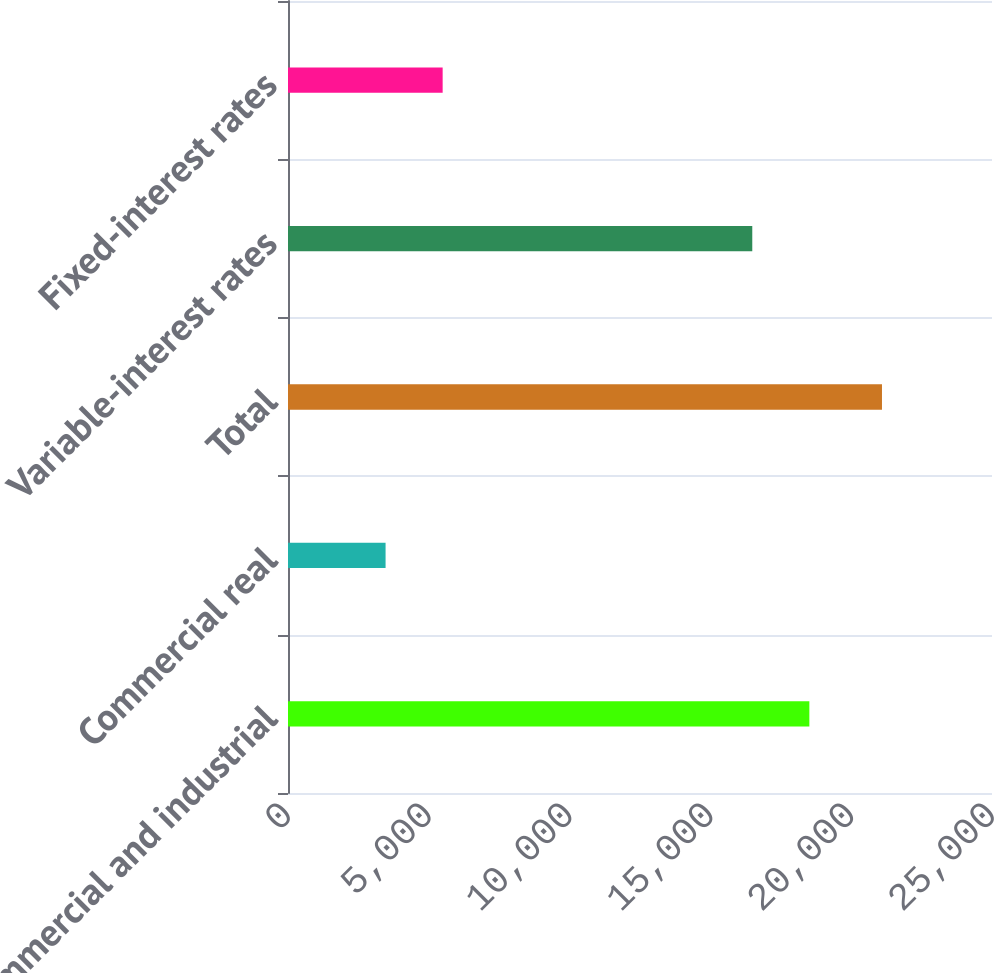<chart> <loc_0><loc_0><loc_500><loc_500><bar_chart><fcel>Commercial and industrial<fcel>Commercial real<fcel>Total<fcel>Variable-interest rates<fcel>Fixed-interest rates<nl><fcel>18514<fcel>3465<fcel>21093<fcel>16487<fcel>5492<nl></chart> 